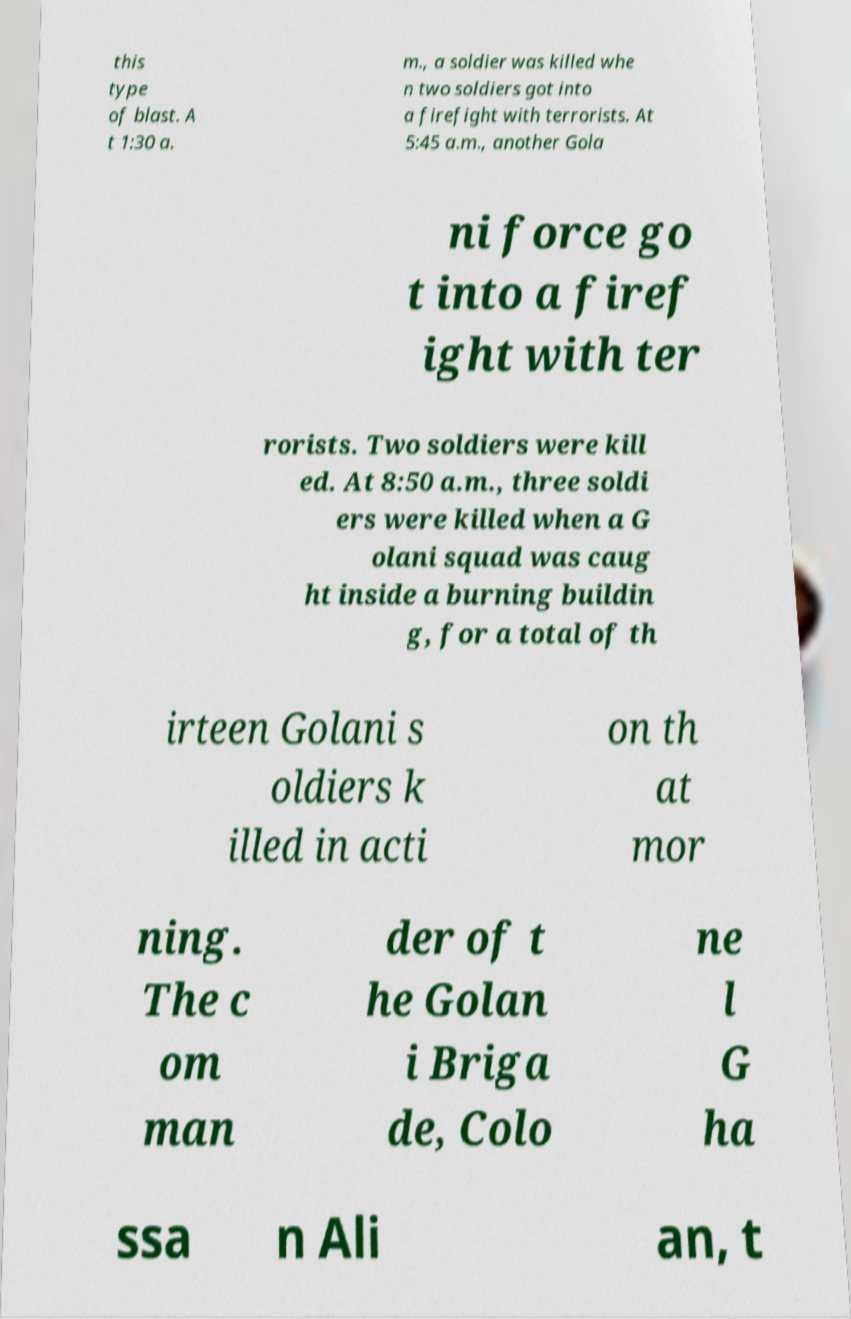I need the written content from this picture converted into text. Can you do that? this type of blast. A t 1:30 a. m., a soldier was killed whe n two soldiers got into a firefight with terrorists. At 5:45 a.m., another Gola ni force go t into a firef ight with ter rorists. Two soldiers were kill ed. At 8:50 a.m., three soldi ers were killed when a G olani squad was caug ht inside a burning buildin g, for a total of th irteen Golani s oldiers k illed in acti on th at mor ning. The c om man der of t he Golan i Briga de, Colo ne l G ha ssa n Ali an, t 